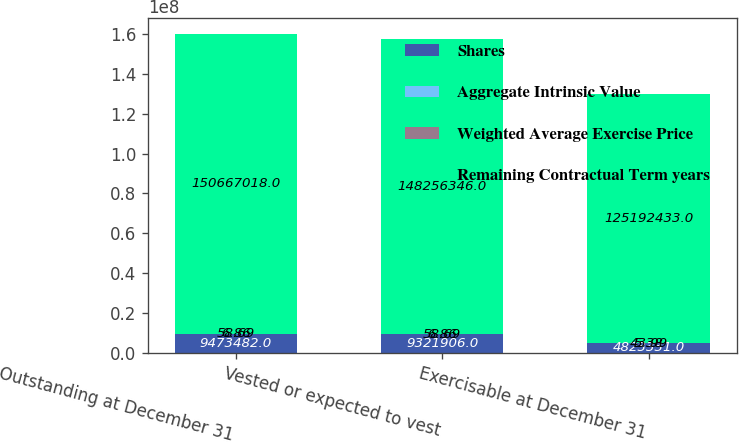Convert chart. <chart><loc_0><loc_0><loc_500><loc_500><stacked_bar_chart><ecel><fcel>Outstanding at December 31<fcel>Vested or expected to vest<fcel>Exercisable at December 31<nl><fcel>Shares<fcel>9.47348e+06<fcel>9.32191e+06<fcel>4.82333e+06<nl><fcel>Aggregate Intrinsic Value<fcel>58.69<fcel>58.69<fcel>43.99<nl><fcel>Weighted Average Exercise Price<fcel>6.86<fcel>6.86<fcel>5.38<nl><fcel>Remaining Contractual Term years<fcel>1.50667e+08<fcel>1.48256e+08<fcel>1.25192e+08<nl></chart> 